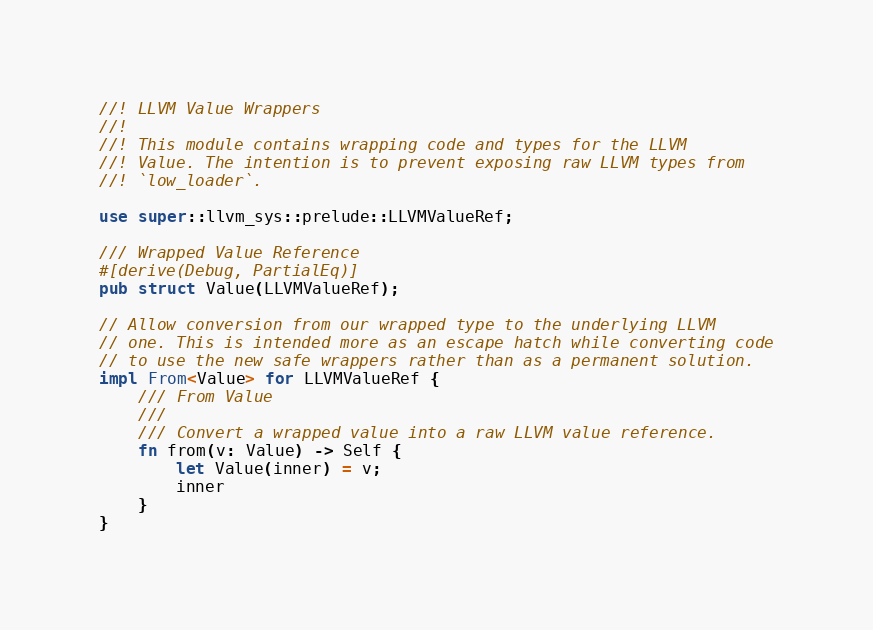Convert code to text. <code><loc_0><loc_0><loc_500><loc_500><_Rust_>//! LLVM Value Wrappers
//!
//! This module contains wrapping code and types for the LLVM
//! Value. The intention is to prevent exposing raw LLVM types from
//! `low_loader`.

use super::llvm_sys::prelude::LLVMValueRef;

/// Wrapped Value Reference
#[derive(Debug, PartialEq)]
pub struct Value(LLVMValueRef);

// Allow conversion from our wrapped type to the underlying LLVM
// one. This is intended more as an escape hatch while converting code
// to use the new safe wrappers rather than as a permanent solution.
impl From<Value> for LLVMValueRef {
    /// From Value
    ///
    /// Convert a wrapped value into a raw LLVM value reference.
    fn from(v: Value) -> Self {
        let Value(inner) = v;
        inner
    }
}
</code> 